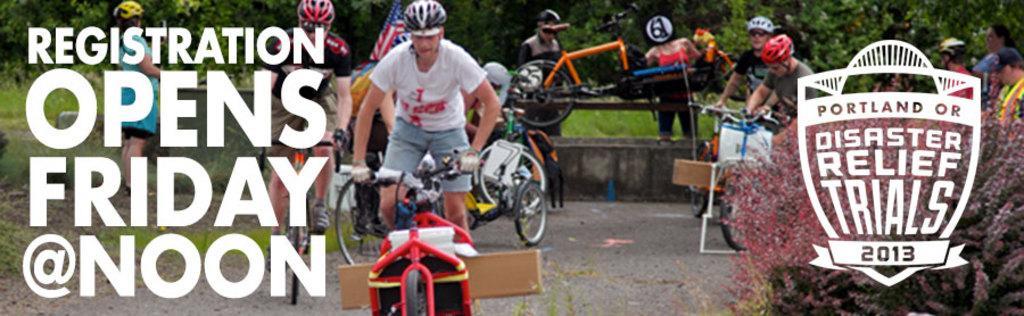Could you give a brief overview of what you see in this image? In the image there is a poster. In the poster there are few people with helmets on their heads. And there are riding bicycles. And also there are few people standing. In the background there are trees and also is a small wall. On the left side of the image there is something written on it. And on the right side corner of the image there is a logo. 